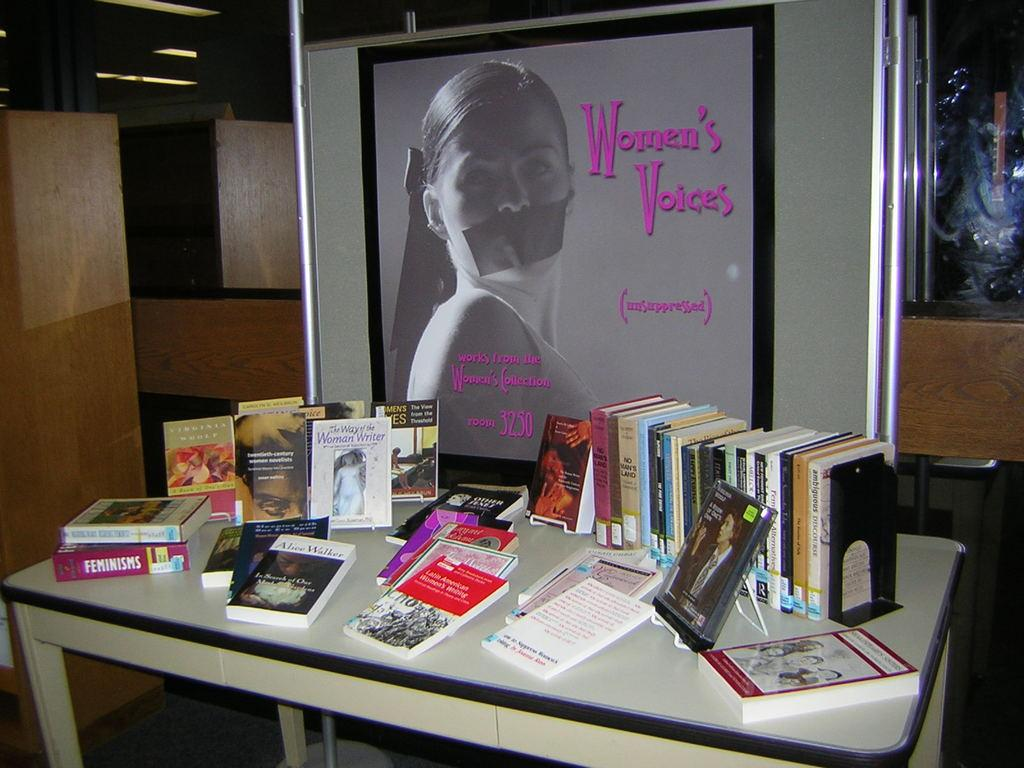<image>
Give a short and clear explanation of the subsequent image. Table with books on it and a picture that says Women's Voices 